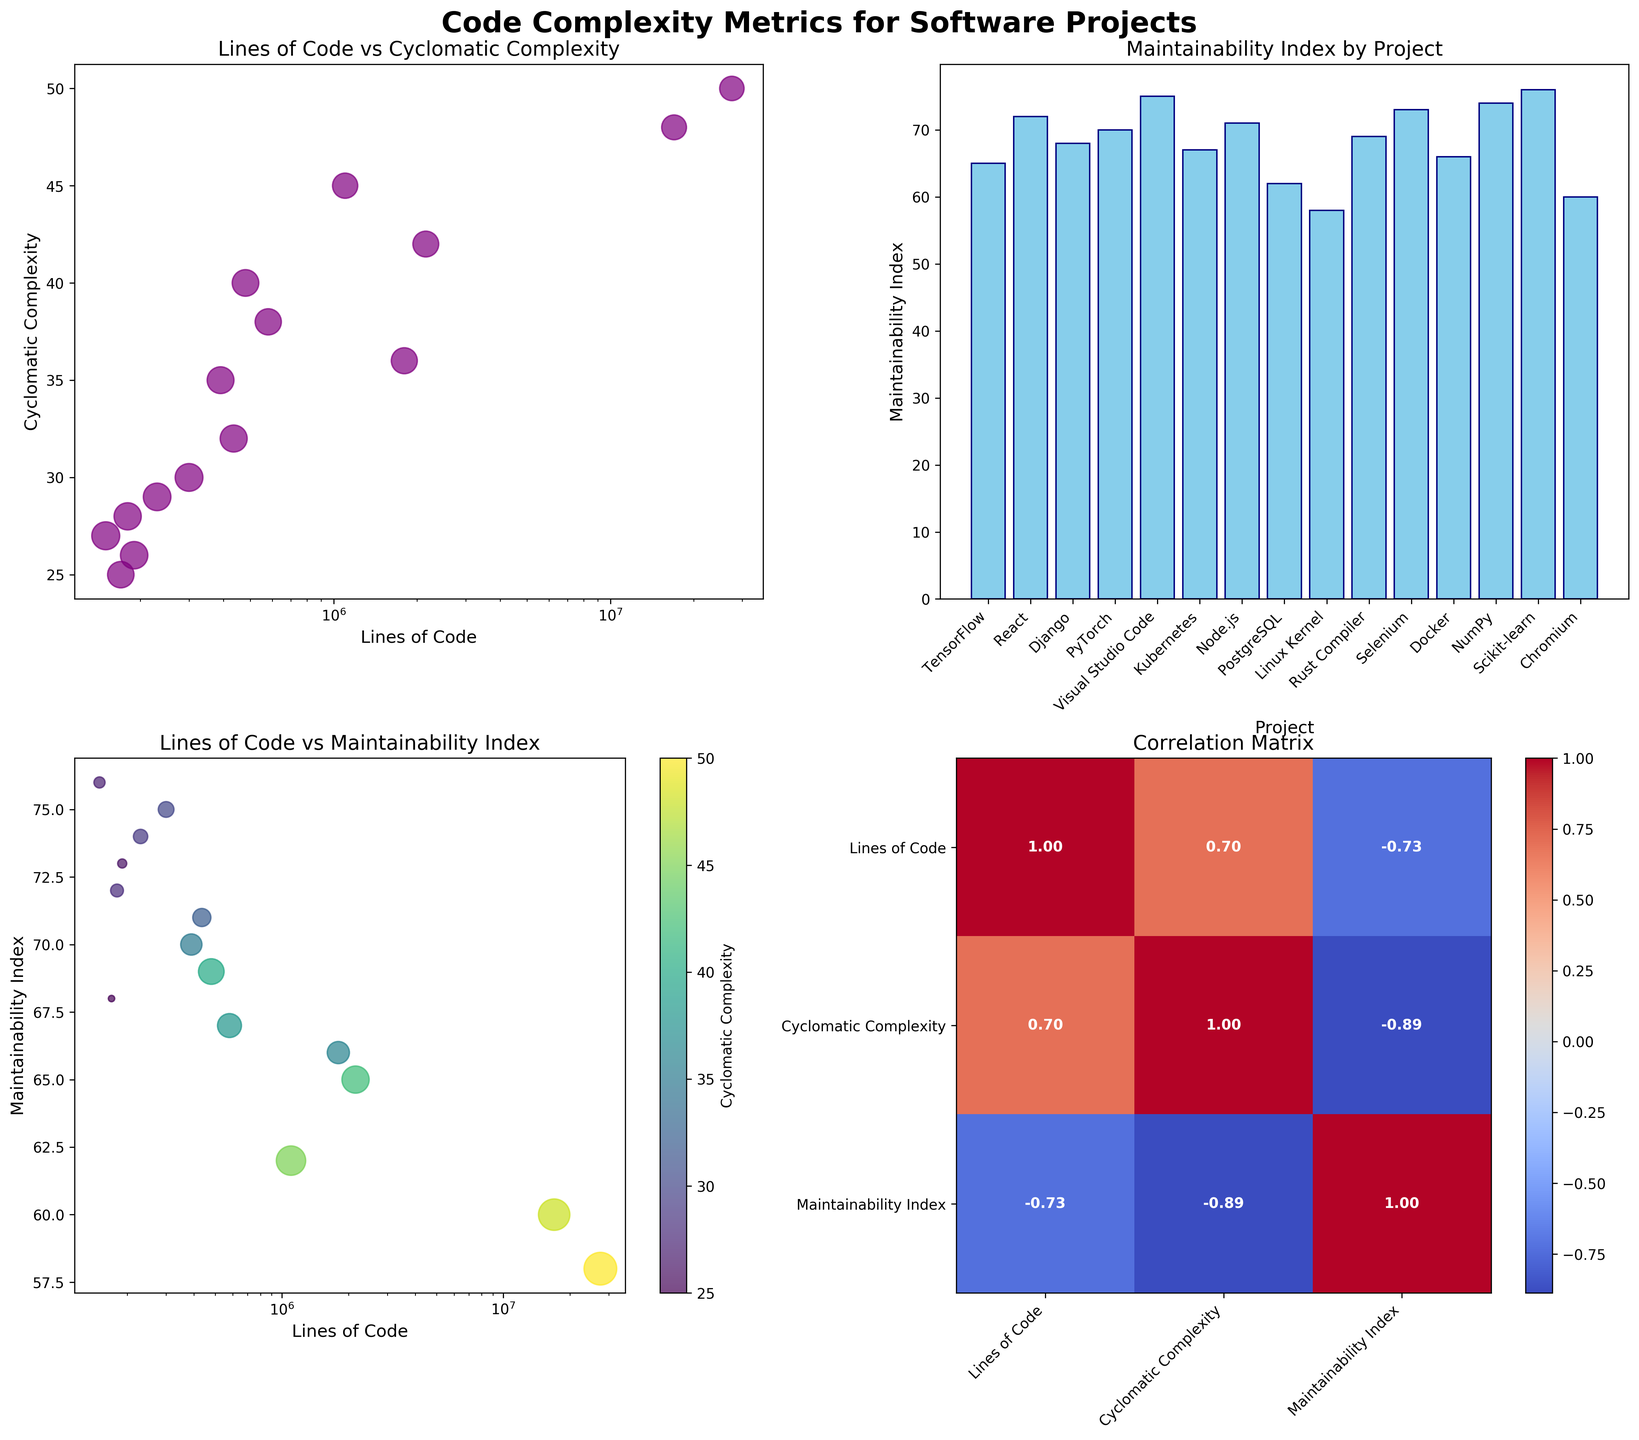What is the title of the entire figure? The title is displayed at the top center of the entire figure. It reads "Code Complexity Metrics for Software Projects".
Answer: Code Complexity Metrics for Software Projects Which project has the highest Cyclomatic Complexity? Referring to the scatter plot (top left), PostgreSQL stands out with a Cyclomatic Complexity of 45.
Answer: PostgreSQL How many data points are represented in the scatter plot of Lines of Code vs Cyclomatic Complexity? The scatter plot has one data point for each software project. By counting the unique markers in the scatter plot, we see there are 15 projects displayed.
Answer: 15 Which project has the lowest Maintainability Index? The bar plot (top right) helps identify the project with the lowest bar, which is the Linux Kernel with a Maintainability Index of 58.
Answer: Linux Kernel Compare TensorFlow and React in terms of Lines of Code and Maintainability Index. Which has fewer lines of code? Which has a higher maintainability index? Referring to the scatter plots and bar plot:
- TensorFlow has 2,153,000 lines of code and a maintainability index around 65.
- React has 180,000 lines of code and a maintainability index around 72.
Hence, React has fewer lines of code and a higher maintainability index.
Answer: React, React What is the general correlation between Lines of Code and Maintainability Index as shown in the correlation matrix? In the heatmap (bottom right), the correlation coefficient between Lines of Code and Maintainability Index can be found. It appears as a moderately negative value, indicating that as Lines of Code increase, Maintainability Index generally decreases.
Answer: Negative correlation What does the color represent in the bubble plot of Lines of Code vs Maintainability Index? The bubble plot (bottom left) uses color to represent Cyclomatic Complexity, with a color gradient from the viridis colormap.
Answer: Cyclomatic Complexity Which two projects appear to have the closest Cyclomatic Complexity, despite differences in Lines of Code? Referring to the scatter plot (top left) and considering data points close to each other in Cyclomatic Complexity: React (28) and Scikit-learn (27) appear close despite differences in Lines of Code (180,000 and 150,000 respectively).
Answer: React and Scikit-learn What feature does the size of the bubbles in the bottom left plot represent? In the bubble plot (bottom left), the size of each bubble correlates with Cyclomatic Complexity but scaled. More complexity results in larger bubbles.
Answer: Cyclomatic Complexity Is there a positive or negative correlation between Cyclomatic Complexity and Maintainability Index? Using the correlation matrix (bottom right), the correlation value between Cyclomatic Complexity and Maintainability Index can be read. It's slightly negative, suggesting a weak to moderate inverse relationship.
Answer: Negative 